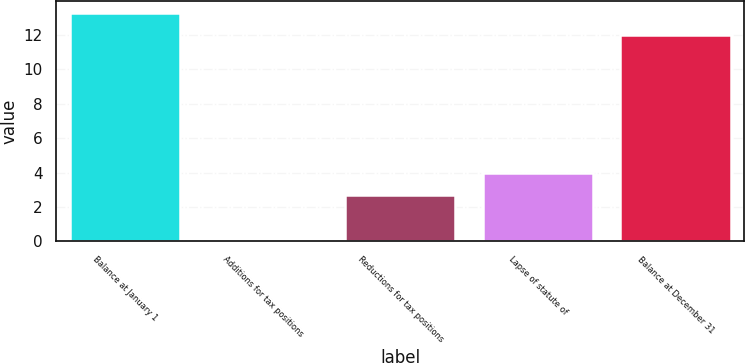Convert chart to OTSL. <chart><loc_0><loc_0><loc_500><loc_500><bar_chart><fcel>Balance at January 1<fcel>Additions for tax positions<fcel>Reductions for tax positions<fcel>Lapse of statute of<fcel>Balance at December 31<nl><fcel>13.3<fcel>0.1<fcel>2.7<fcel>4<fcel>12<nl></chart> 